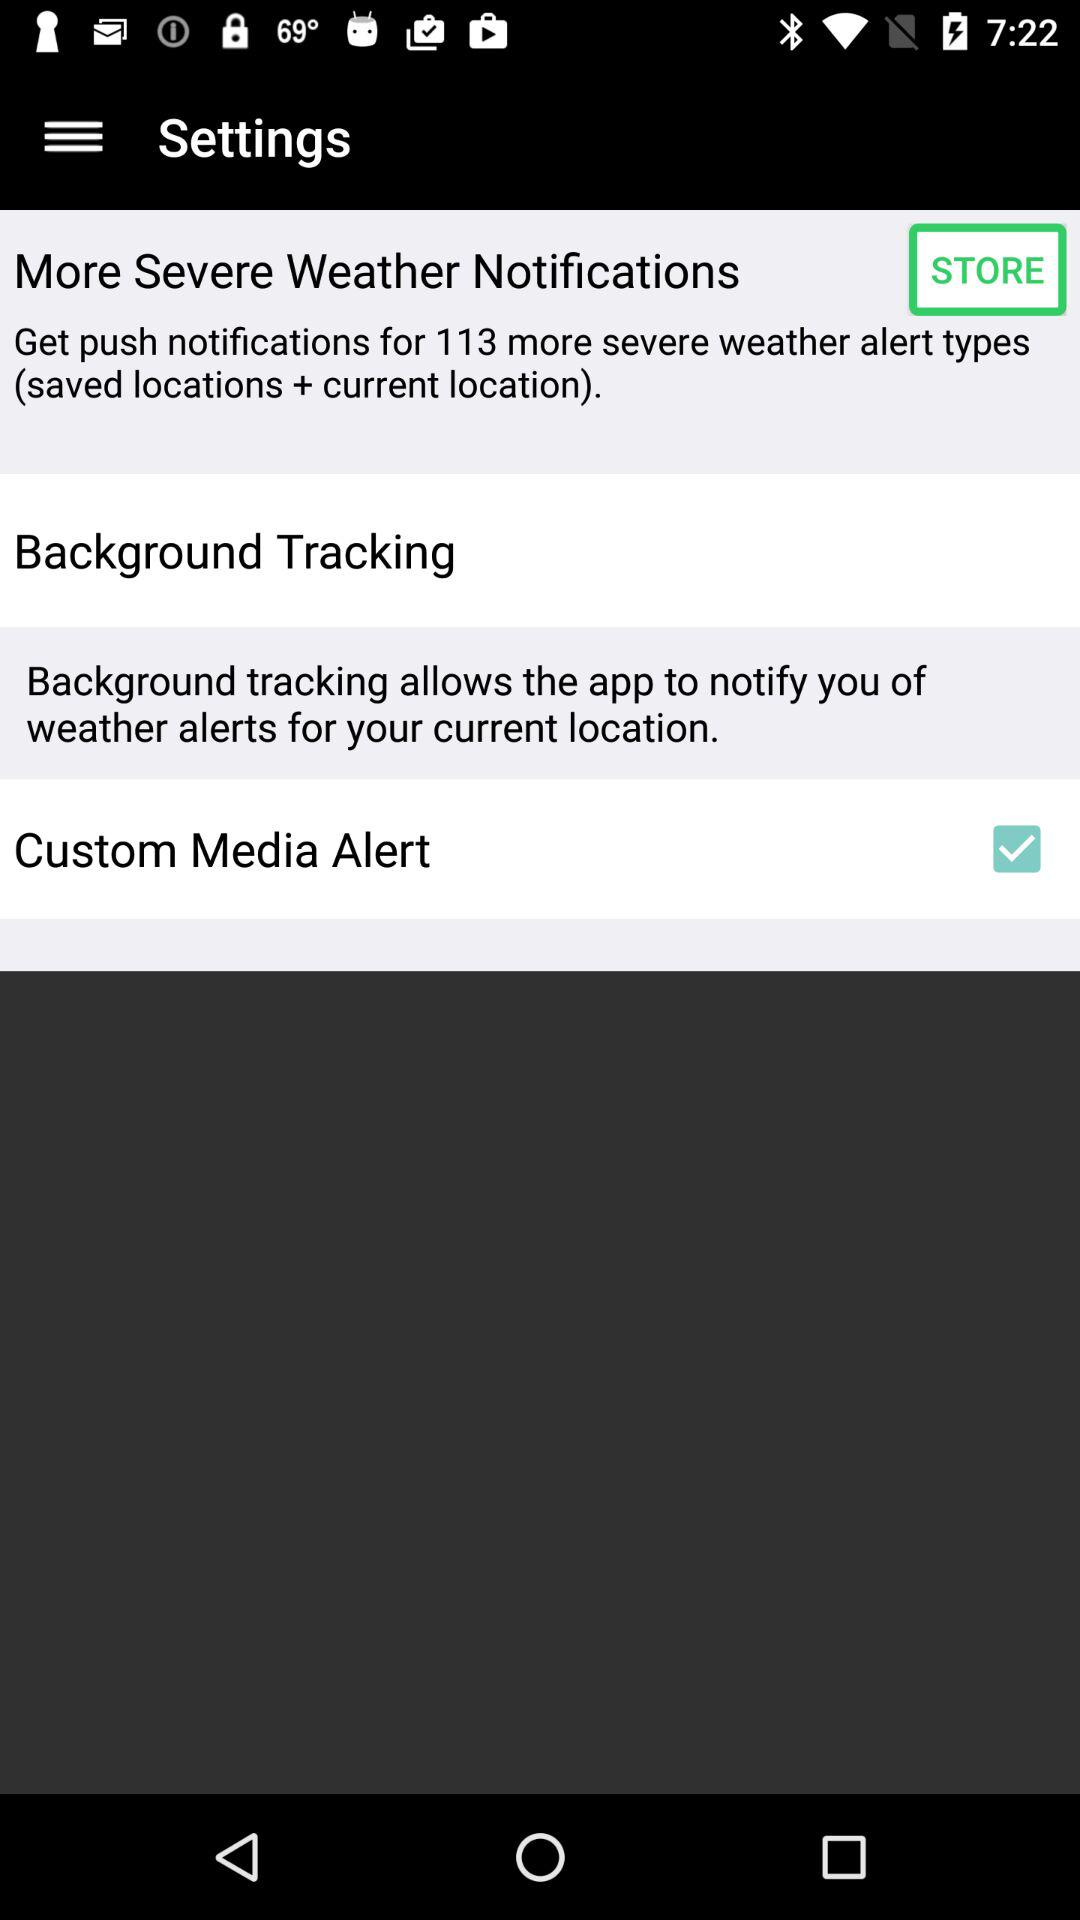How many more severe weather alert types can I get push notifications for?
Answer the question using a single word or phrase. 113 